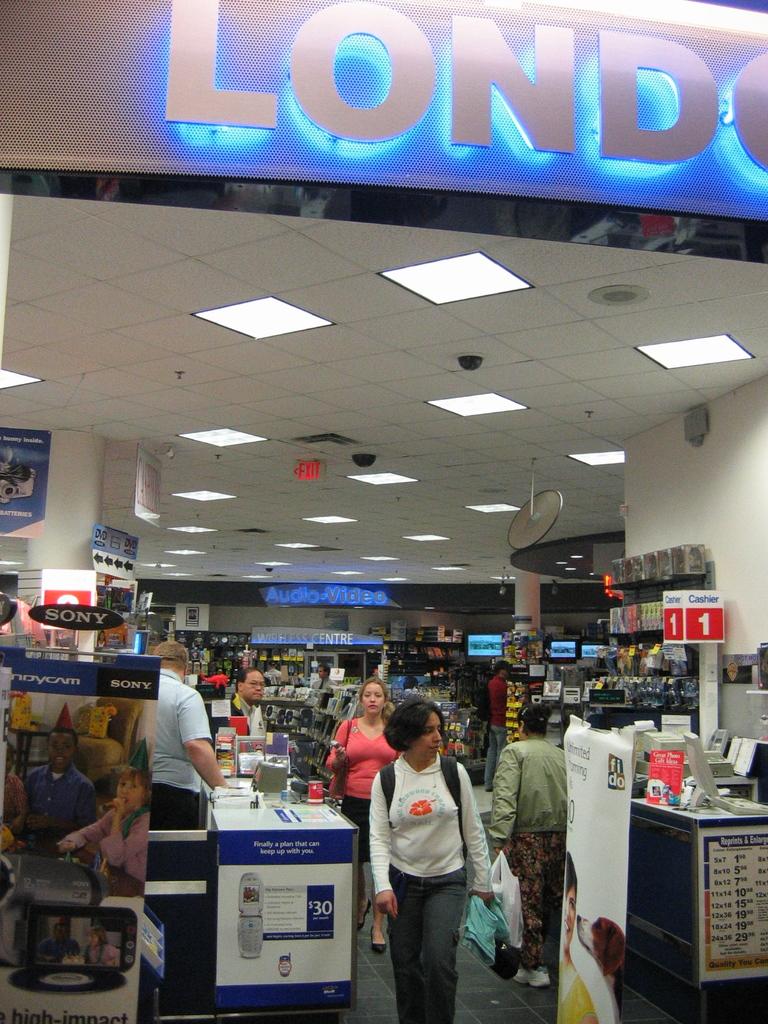Which brand is feature on the black sign on the left?
Your answer should be very brief. Sony. What number is on the register sign on the right?
Offer a terse response. 1. 